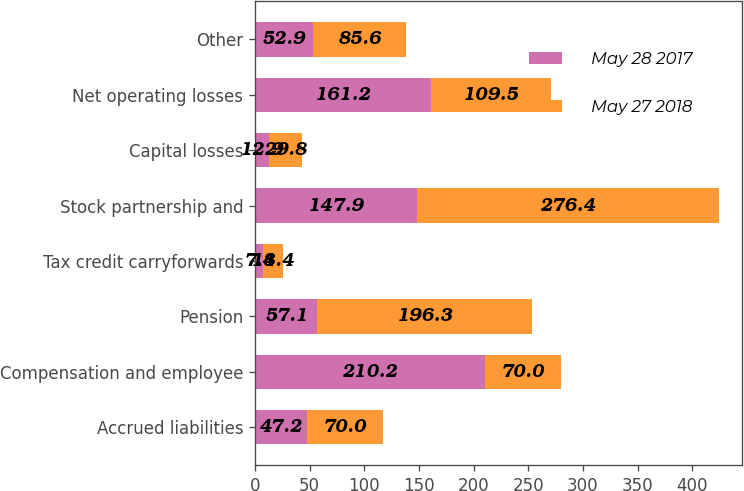Convert chart. <chart><loc_0><loc_0><loc_500><loc_500><stacked_bar_chart><ecel><fcel>Accrued liabilities<fcel>Compensation and employee<fcel>Pension<fcel>Tax credit carryforwards<fcel>Stock partnership and<fcel>Capital losses<fcel>Net operating losses<fcel>Other<nl><fcel>May 28 2017<fcel>47.2<fcel>210.2<fcel>57.1<fcel>7.4<fcel>147.9<fcel>12.9<fcel>161.2<fcel>52.9<nl><fcel>May 27 2018<fcel>70<fcel>70<fcel>196.3<fcel>18.4<fcel>276.4<fcel>29.8<fcel>109.5<fcel>85.6<nl></chart> 